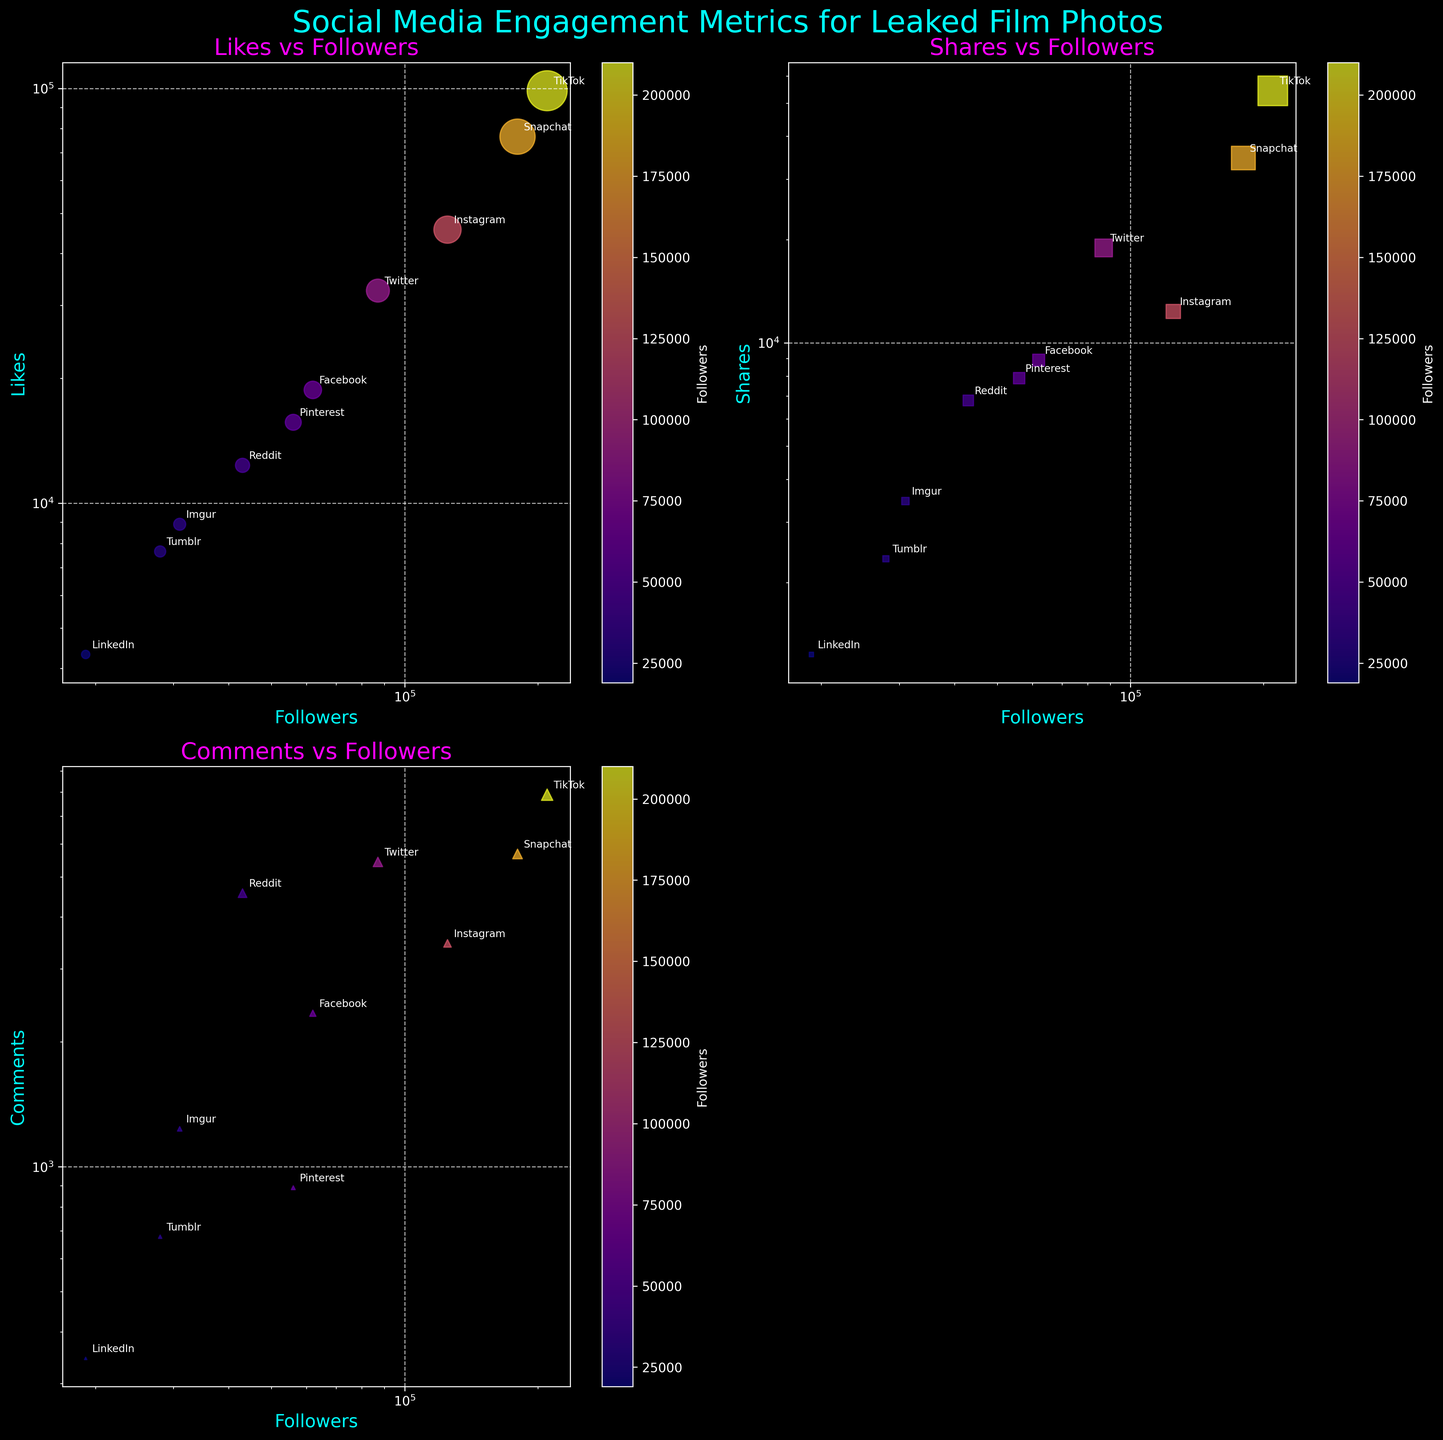What is the title of the figure? The title is written at the top of the figure. It provides a clear indication of what the figure is about.
Answer: Social Media Engagement Metrics for Leaked Film Photos How many scatter plots are shown in the figure? By looking at the figure, you can see there are three scatter plots, each in a separate subplot, among the four subplots.
Answer: 3 Which platform has the highest number of followers? By checking the scatter plots and observing the data points with the highest x-values, the platform with the highest number of followers can be identified.
Answer: TikTok What is the relationship between likes and followers on Instagram, according to the figure? Locate the point for Instagram in the likes vs followers plot and observe its position and pattern. This data point shows how many likes and followers Instagram has, which you can compare directly.
Answer: Instagram has around 45,678 likes for 125,000 followers For which metric is Snapchat performing the best among all platforms displayed? By examining the scatter plots for likes, shares, and comments, find the data point representing Snapchat and compare its values across these metrics.
Answer: Snapchat has the highest number of shares Which platform has the lowest number of comments? Look at the comments vs followers subplot and find the data point with the lowest y-value.
Answer: Tumblr Which two platforms have similar numbers of followers but differ significantly in another engagement metric? Identify platforms close together on the x-axis (followers) and compare their y-values (likes, shares, comments) for a notable difference.
Answer: Facebook and Tumblr have similar followers but differ significantly in comments Which metric shows a stronger positive correlation with followers? Observe the scatter plots for likes vs followers, shares vs followers, and comments vs followers, and determine which shows a more distinct upward trend.
Answer: Likes vs Followers Comparing the 'Dune Part 2 costume reveal' and 'Avatar 3 creature design', which has more comments? Use the comments vs followers subplot, locate these two data points, and compare their y-values.
Answer: Dune Part 2 costume reveal Which platform's data point is located at the highest position on the 'Shares vs Followers' plot? Look at the scatter plot for shares vs followers and identify the data point at the highest y-value.
Answer: TikTok 